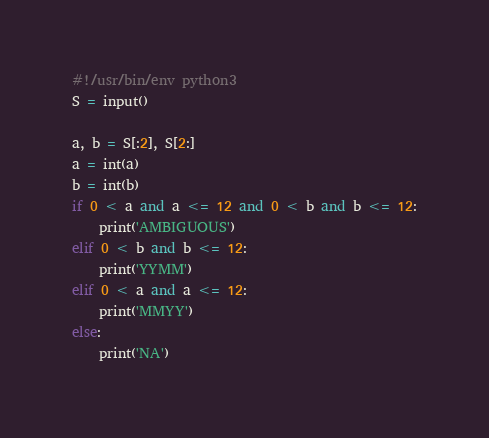<code> <loc_0><loc_0><loc_500><loc_500><_Python_>#!/usr/bin/env python3
S = input()

a, b = S[:2], S[2:]
a = int(a)
b = int(b)
if 0 < a and a <= 12 and 0 < b and b <= 12:
    print('AMBIGUOUS')
elif 0 < b and b <= 12:
    print('YYMM')
elif 0 < a and a <= 12:
    print('MMYY')
else:
    print('NA')
</code> 